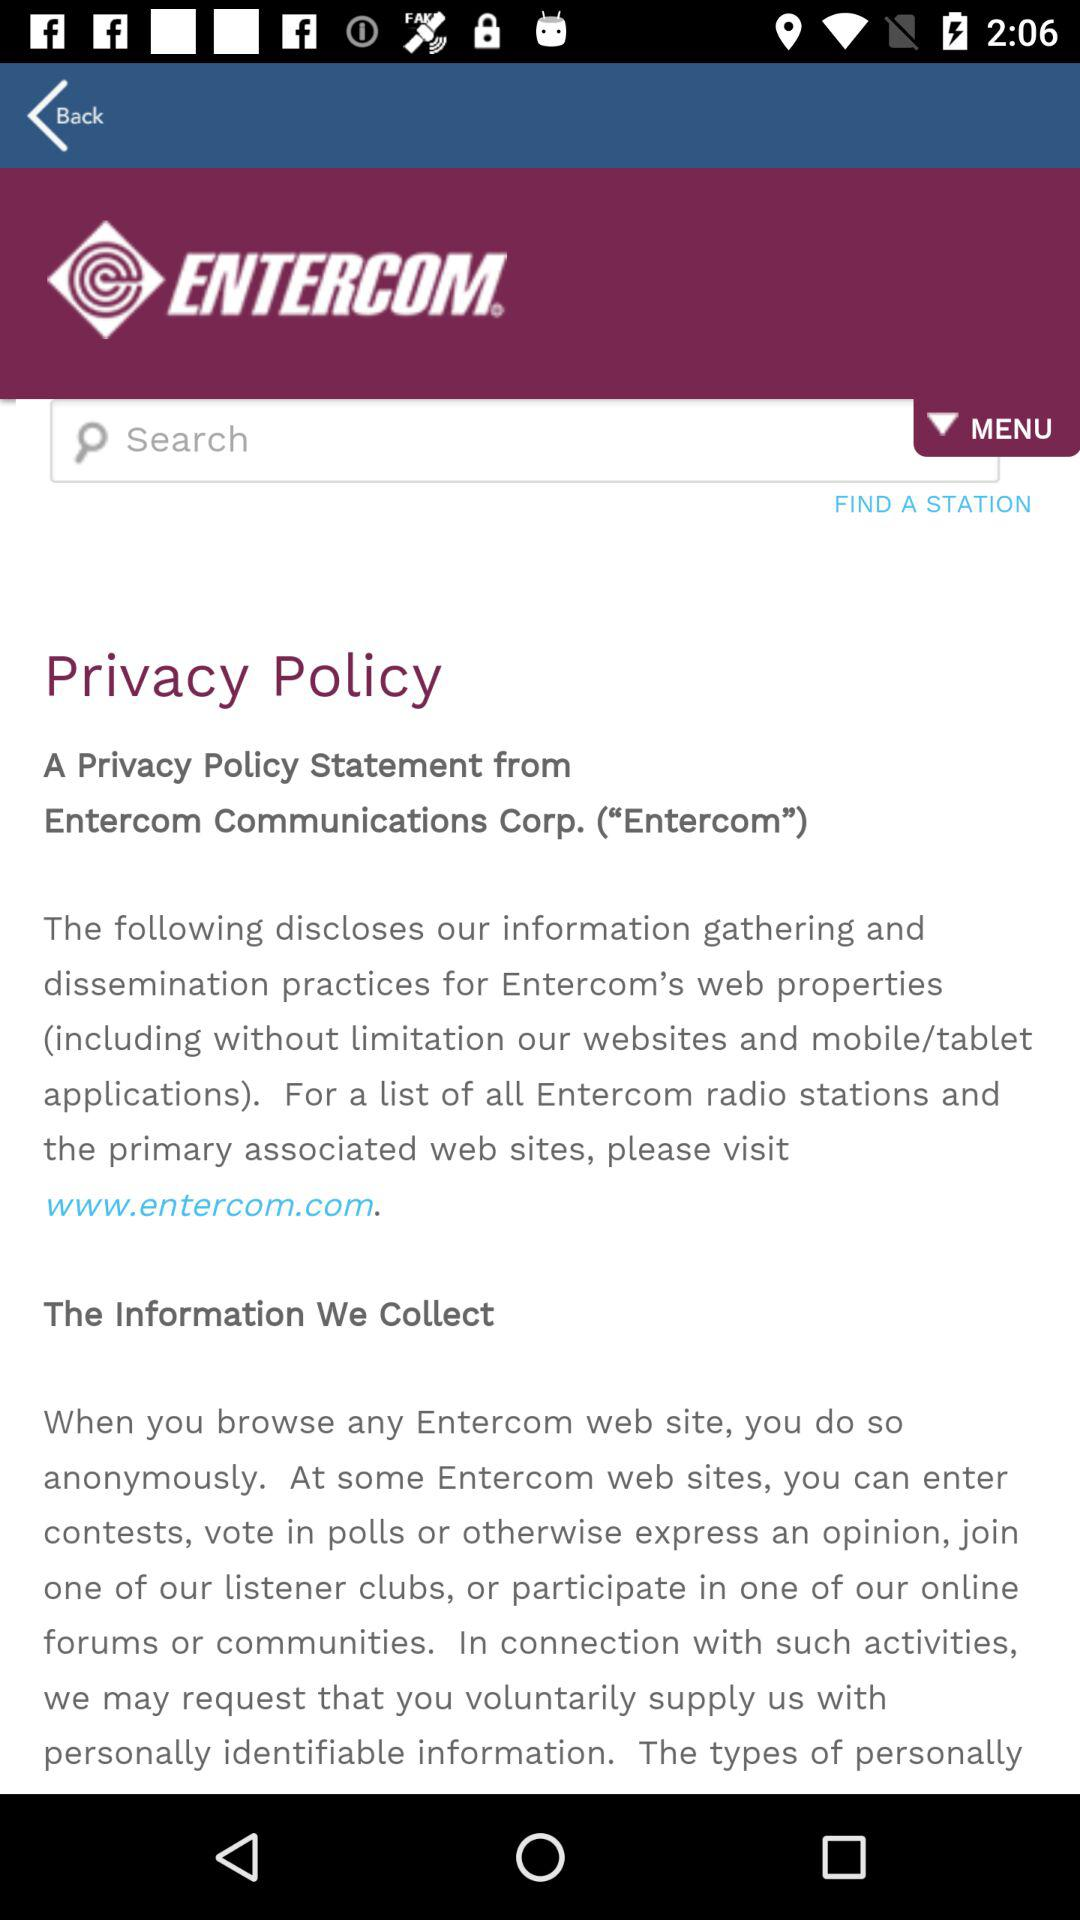What is the application name?
When the provided information is insufficient, respond with <no answer>. <no answer> 